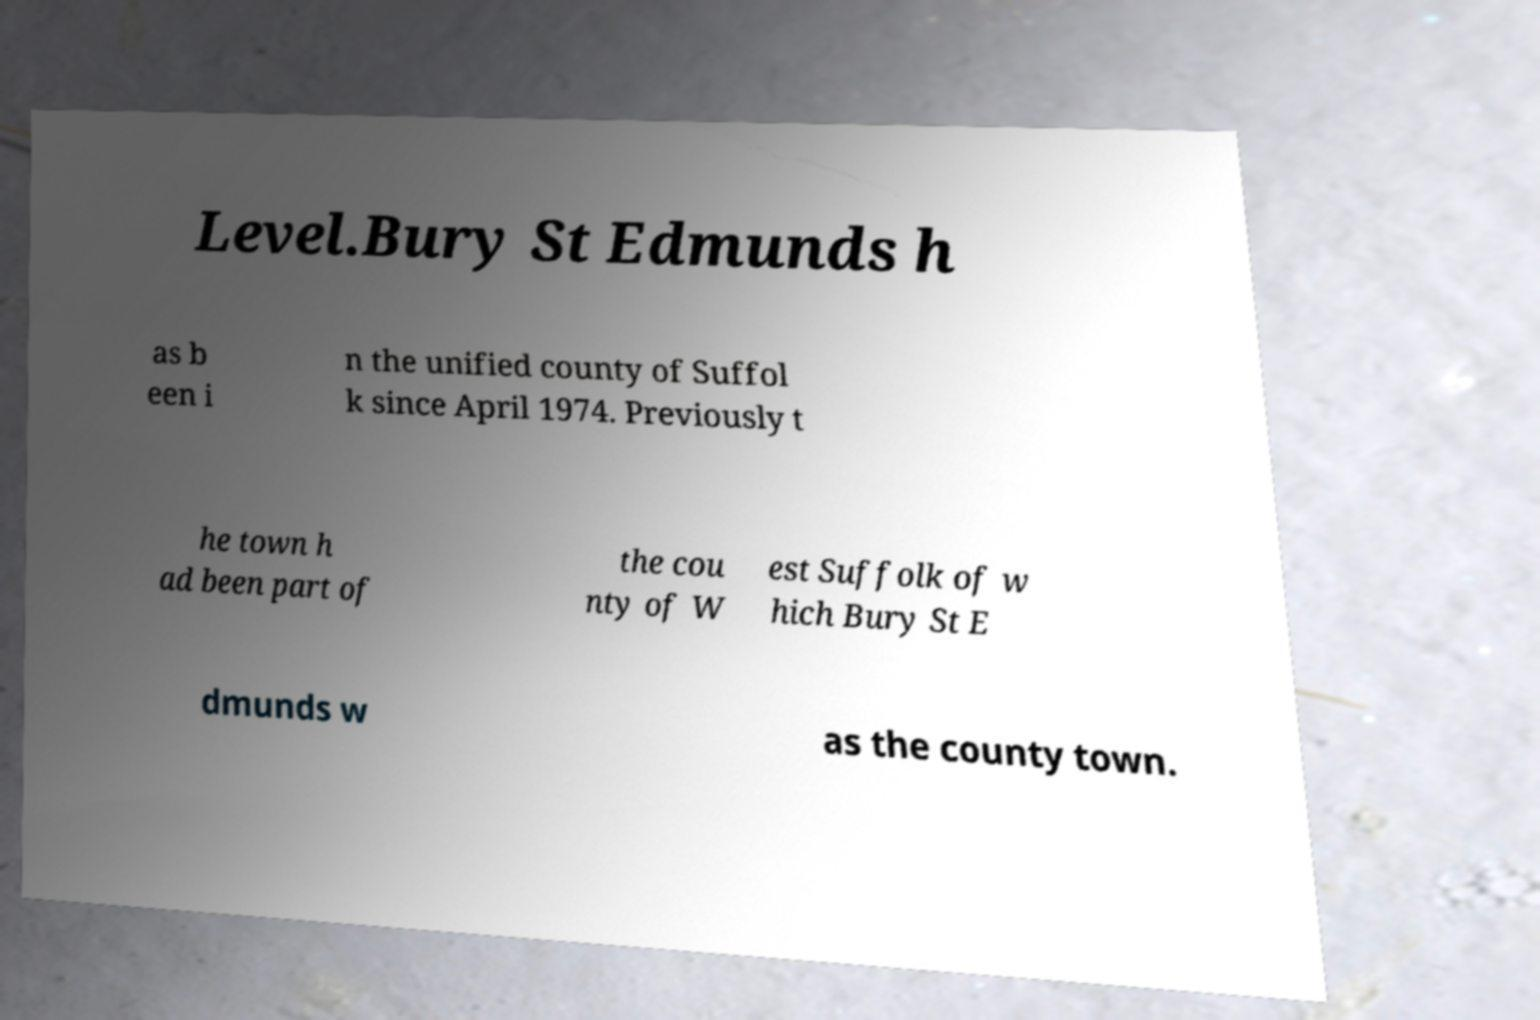I need the written content from this picture converted into text. Can you do that? Level.Bury St Edmunds h as b een i n the unified county of Suffol k since April 1974. Previously t he town h ad been part of the cou nty of W est Suffolk of w hich Bury St E dmunds w as the county town. 